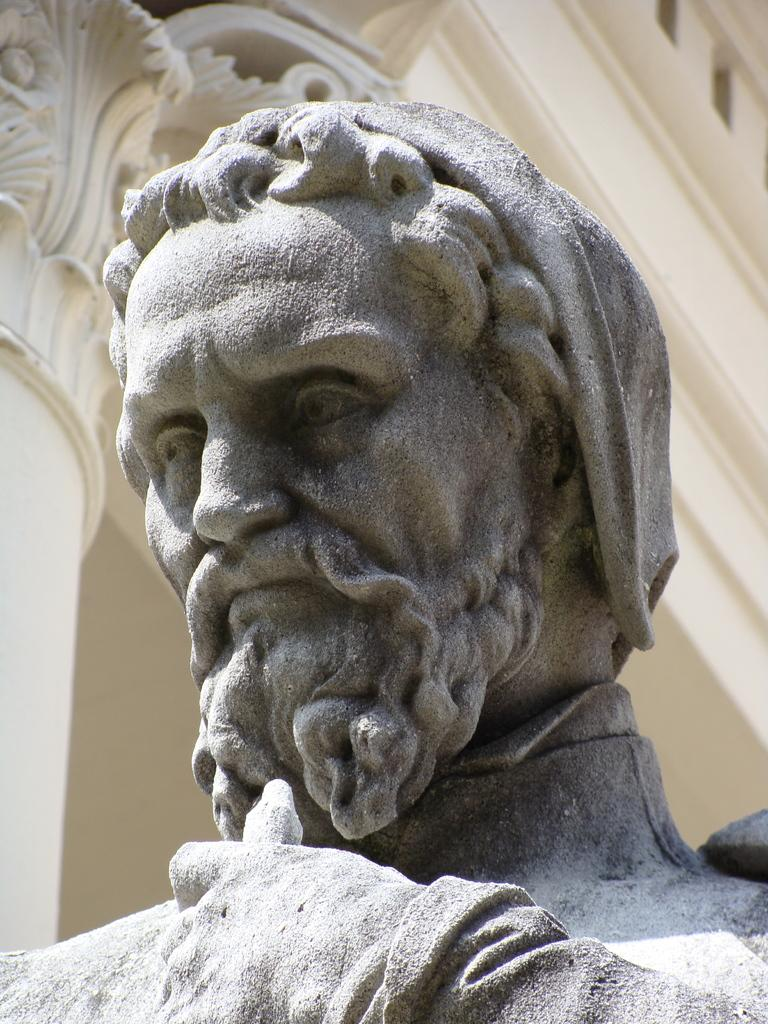What is the main subject of the image? There is a statue of a man in the image. What can be seen in the background of the image? There is a building and a pillar in the background of the image. What type of insect can be seen crawling on the statue in the image? There is no insect visible on the statue in the image. What season is depicted in the image? The image does not depict a specific season, as there are no seasonal elements present. 